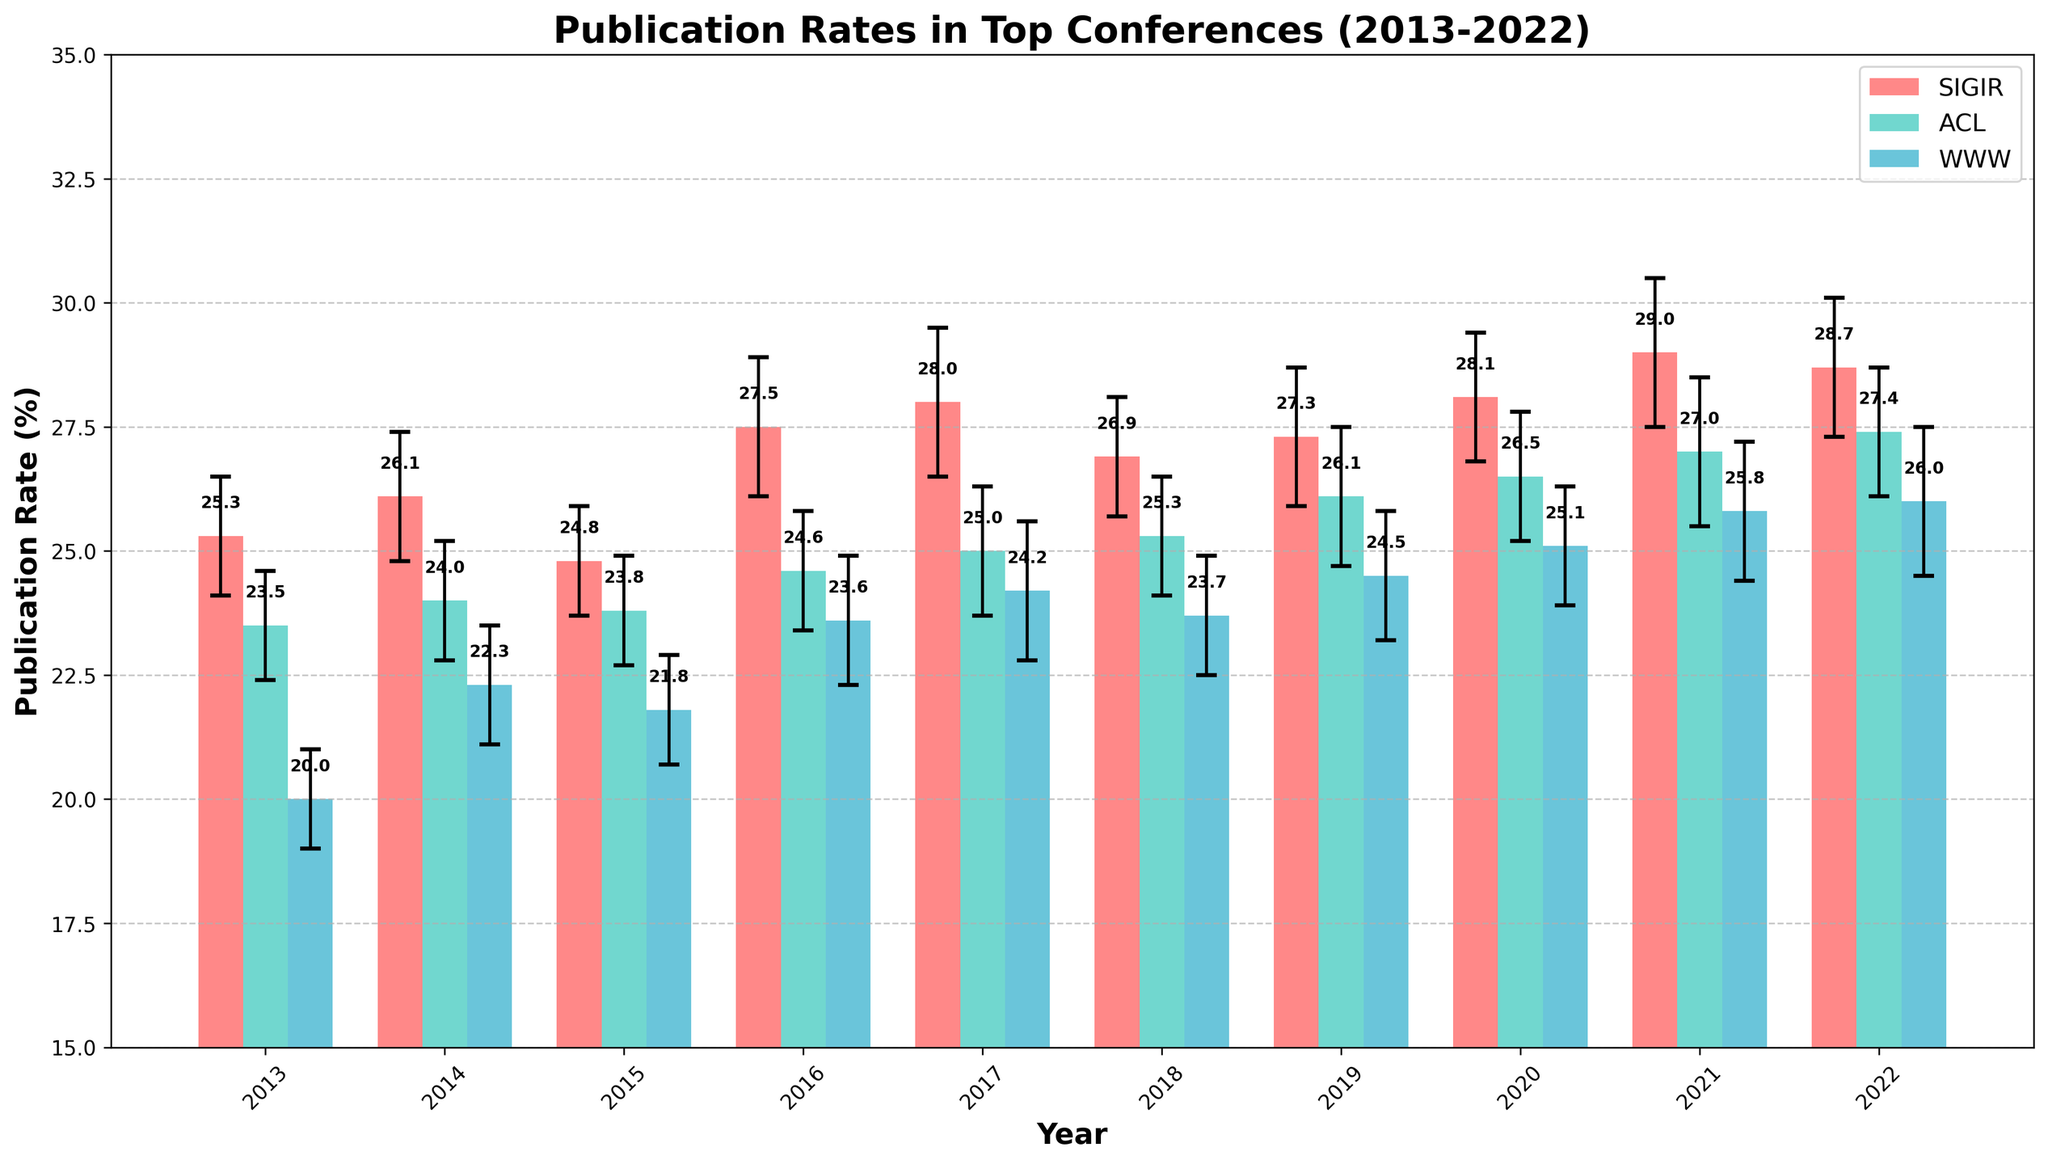What is the title of the figure? The title of a figure is usually located at the top and summarizes the main information being displayed. In this case, the title is prominently displayed as 'Publication Rates in Top Conferences (2013-2022)'.
Answer: Publication Rates in Top Conferences (2013-2022) What is the publication rate for SIGIR in 2018? Look for the bar corresponding to SIGIR for the year 2018. The number at the top of the bar or the height of the bar gives the publication rate.
Answer: 26.9% Which conference had the lowest publication rate in 2013? Locate the bars for each conference in the year 2013. Compare the heights of these bars to find the lowest one, which corresponds to the WWW conference.
Answer: WWW How does the publication rate of ACL in 2016 compare to 2015? Find the bars for ACL for the years 2016 and 2015. Compare their heights to determine which is higher and, therefore, understand how the publication rate has changed from one year to the next.
Answer: Higher in 2016 What is the overall trend of the publication rate for SIGIR from 2013 to 2022? Observe the overall shape and direction of the bars for SIGIR from 2013 to 2022. If the bars generally increase in height, it's an upward trend; if they decrease, it is a downward trend.
Answer: Upward trend In which year did WWW have the highest publication rate? Look for the tallest bar corresponding to the WWW conference across all years. Identify the year associated with this bar.
Answer: 2022 What is the difference in publication rates between SIGIR and ACL in 2020? Locate the bars for SIGIR and ACL for the year 2020. Subtract the height (publication rate) of the ACL bar from the SIGIR bar to find the difference.
Answer: 1.6% What are the margin of errors for ACL in 2021 and 2022? Margin of error bars are shown as small vertical lines on top of the bars. For ACL, observe these error bars in 2021 and 2022 and read off the values.
Answer: 1.5% for 2021, 1.3% for 2022 Considering the margin of error, is the publication rate for SIGIR in 2020 significantly different from 2019? Compare the publication rates and their margin of error bars for SIGIR for 2020 and 2019. Determine if the ranges overlap to evaluate if the difference might be significant.
Answer: Not significantly different (Roughly overlapping ranges) Which conference exhibits the most consistent publication rates over the years? Look at the height of the bars for each conference over the years. A conference with smaller fluctuations in heights shows more consistency.
Answer: ACL 